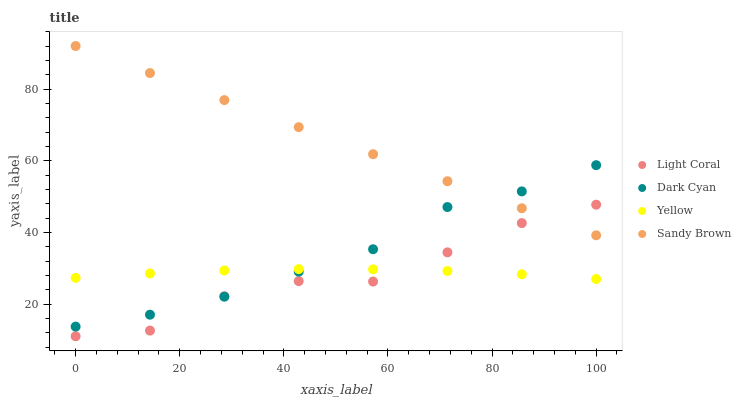Does Light Coral have the minimum area under the curve?
Answer yes or no. Yes. Does Sandy Brown have the maximum area under the curve?
Answer yes or no. Yes. Does Dark Cyan have the minimum area under the curve?
Answer yes or no. No. Does Dark Cyan have the maximum area under the curve?
Answer yes or no. No. Is Sandy Brown the smoothest?
Answer yes or no. Yes. Is Light Coral the roughest?
Answer yes or no. Yes. Is Dark Cyan the smoothest?
Answer yes or no. No. Is Dark Cyan the roughest?
Answer yes or no. No. Does Light Coral have the lowest value?
Answer yes or no. Yes. Does Dark Cyan have the lowest value?
Answer yes or no. No. Does Sandy Brown have the highest value?
Answer yes or no. Yes. Does Dark Cyan have the highest value?
Answer yes or no. No. Is Yellow less than Sandy Brown?
Answer yes or no. Yes. Is Sandy Brown greater than Yellow?
Answer yes or no. Yes. Does Light Coral intersect Sandy Brown?
Answer yes or no. Yes. Is Light Coral less than Sandy Brown?
Answer yes or no. No. Is Light Coral greater than Sandy Brown?
Answer yes or no. No. Does Yellow intersect Sandy Brown?
Answer yes or no. No. 